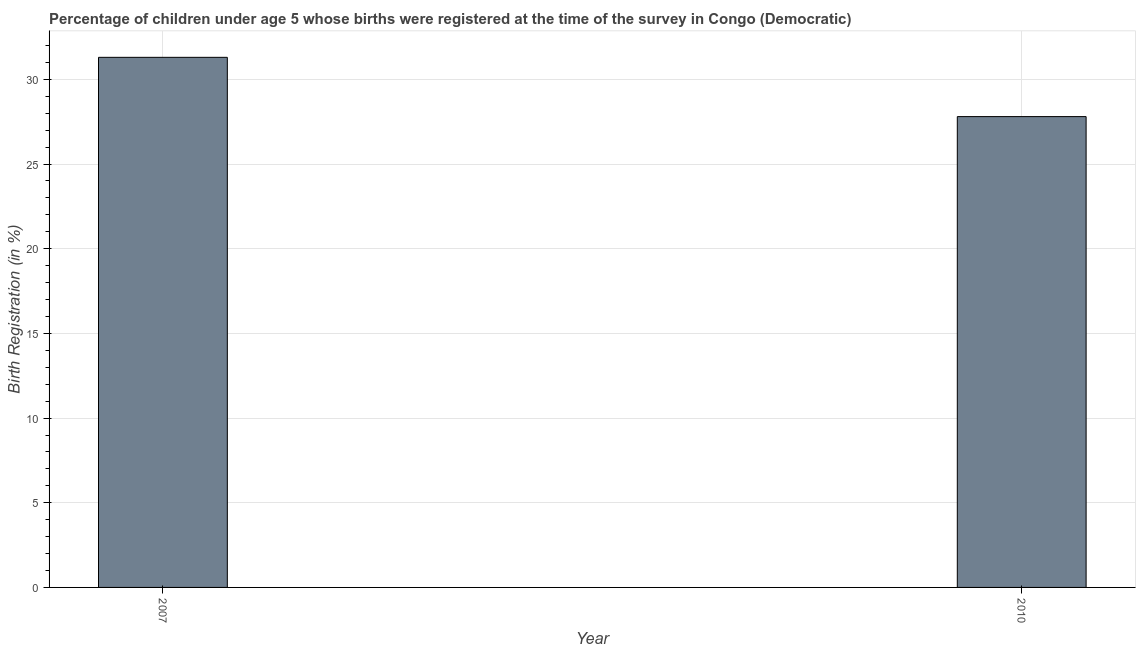Does the graph contain any zero values?
Provide a short and direct response. No. Does the graph contain grids?
Your response must be concise. Yes. What is the title of the graph?
Provide a succinct answer. Percentage of children under age 5 whose births were registered at the time of the survey in Congo (Democratic). What is the label or title of the Y-axis?
Ensure brevity in your answer.  Birth Registration (in %). What is the birth registration in 2010?
Keep it short and to the point. 27.8. Across all years, what is the maximum birth registration?
Your answer should be compact. 31.3. Across all years, what is the minimum birth registration?
Keep it short and to the point. 27.8. In which year was the birth registration maximum?
Keep it short and to the point. 2007. In which year was the birth registration minimum?
Your answer should be compact. 2010. What is the sum of the birth registration?
Provide a succinct answer. 59.1. What is the average birth registration per year?
Make the answer very short. 29.55. What is the median birth registration?
Offer a very short reply. 29.55. In how many years, is the birth registration greater than 18 %?
Your answer should be very brief. 2. Do a majority of the years between 2007 and 2010 (inclusive) have birth registration greater than 3 %?
Your answer should be very brief. Yes. What is the ratio of the birth registration in 2007 to that in 2010?
Give a very brief answer. 1.13. Is the birth registration in 2007 less than that in 2010?
Your answer should be compact. No. In how many years, is the birth registration greater than the average birth registration taken over all years?
Your answer should be compact. 1. How many bars are there?
Keep it short and to the point. 2. What is the difference between two consecutive major ticks on the Y-axis?
Your answer should be very brief. 5. Are the values on the major ticks of Y-axis written in scientific E-notation?
Keep it short and to the point. No. What is the Birth Registration (in %) of 2007?
Your answer should be compact. 31.3. What is the Birth Registration (in %) of 2010?
Ensure brevity in your answer.  27.8. What is the ratio of the Birth Registration (in %) in 2007 to that in 2010?
Give a very brief answer. 1.13. 